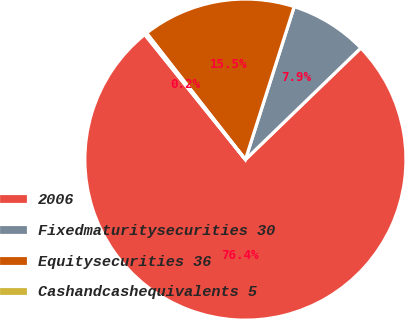Convert chart to OTSL. <chart><loc_0><loc_0><loc_500><loc_500><pie_chart><fcel>2006<fcel>Fixedmaturitysecurities 30<fcel>Equitysecurities 36<fcel>Cashandcashequivalents 5<nl><fcel>76.45%<fcel>7.85%<fcel>15.47%<fcel>0.23%<nl></chart> 